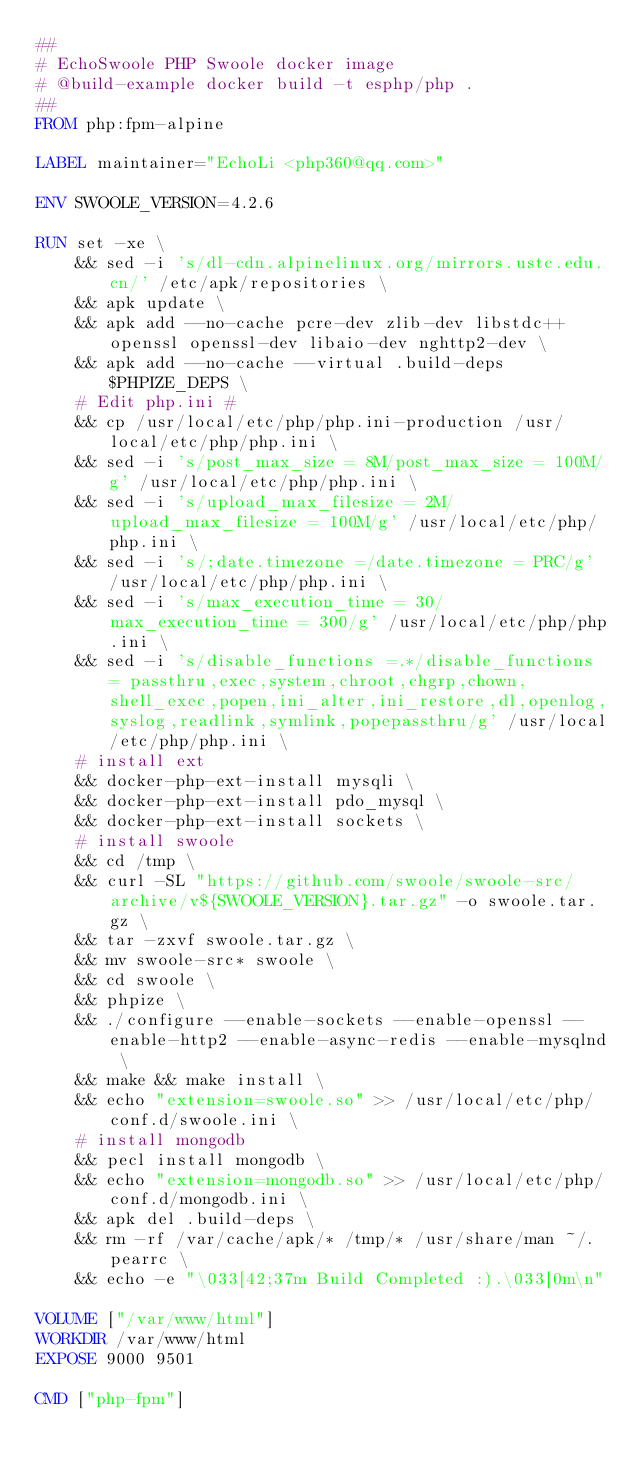<code> <loc_0><loc_0><loc_500><loc_500><_Dockerfile_>##
# EchoSwoole PHP Swoole docker image
# @build-example docker build -t esphp/php .
##
FROM php:fpm-alpine

LABEL maintainer="EchoLi <php360@qq.com>"

ENV SWOOLE_VERSION=4.2.6

RUN set -xe \
    && sed -i 's/dl-cdn.alpinelinux.org/mirrors.ustc.edu.cn/' /etc/apk/repositories \
    && apk update \
    && apk add --no-cache pcre-dev zlib-dev libstdc++ openssl openssl-dev libaio-dev nghttp2-dev \
    && apk add --no-cache --virtual .build-deps $PHPIZE_DEPS \
    # Edit php.ini #
    && cp /usr/local/etc/php/php.ini-production /usr/local/etc/php/php.ini \
    && sed -i 's/post_max_size = 8M/post_max_size = 100M/g' /usr/local/etc/php/php.ini \
    && sed -i 's/upload_max_filesize = 2M/upload_max_filesize = 100M/g' /usr/local/etc/php/php.ini \
    && sed -i 's/;date.timezone =/date.timezone = PRC/g' /usr/local/etc/php/php.ini \
    && sed -i 's/max_execution_time = 30/max_execution_time = 300/g' /usr/local/etc/php/php.ini \
    && sed -i 's/disable_functions =.*/disable_functions = passthru,exec,system,chroot,chgrp,chown,shell_exec,popen,ini_alter,ini_restore,dl,openlog,syslog,readlink,symlink,popepassthru/g' /usr/local/etc/php/php.ini \
    # install ext
    && docker-php-ext-install mysqli \
    && docker-php-ext-install pdo_mysql \
    && docker-php-ext-install sockets \
    # install swoole
    && cd /tmp \
    && curl -SL "https://github.com/swoole/swoole-src/archive/v${SWOOLE_VERSION}.tar.gz" -o swoole.tar.gz \
    && tar -zxvf swoole.tar.gz \
    && mv swoole-src* swoole \
    && cd swoole \
    && phpize \
    && ./configure --enable-sockets --enable-openssl --enable-http2 --enable-async-redis --enable-mysqlnd \
    && make && make install \
    && echo "extension=swoole.so" >> /usr/local/etc/php/conf.d/swoole.ini \
    # install mongodb
    && pecl install mongodb \
    && echo "extension=mongodb.so" >> /usr/local/etc/php/conf.d/mongodb.ini \
    && apk del .build-deps \
    && rm -rf /var/cache/apk/* /tmp/* /usr/share/man ~/.pearrc \
    && echo -e "\033[42;37m Build Completed :).\033[0m\n"

VOLUME ["/var/www/html"]
WORKDIR /var/www/html
EXPOSE 9000 9501

CMD ["php-fpm"]</code> 